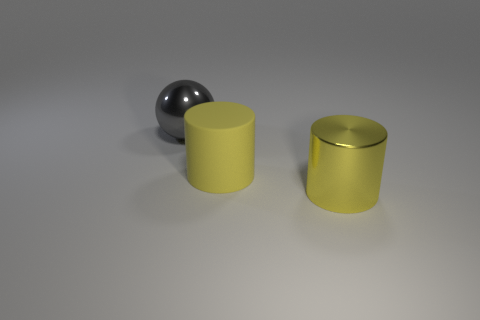Does the rubber cylinder have the same color as the large thing that is right of the large yellow matte cylinder?
Your answer should be compact. Yes. What number of tiny objects are there?
Offer a very short reply. 0. How many shiny objects are big yellow objects or gray objects?
Give a very brief answer. 2. How many metal things have the same color as the large metallic cylinder?
Offer a very short reply. 0. What material is the gray thing left of the big cylinder on the right side of the yellow matte object made of?
Give a very brief answer. Metal. What is the size of the matte cylinder?
Provide a short and direct response. Large. How many brown things are the same size as the gray object?
Offer a terse response. 0. How many other objects are the same shape as the large yellow rubber object?
Offer a very short reply. 1. Is the number of big yellow metal things that are behind the gray sphere the same as the number of large red metallic objects?
Your answer should be very brief. Yes. What shape is the yellow metal object that is the same size as the gray metallic thing?
Your answer should be compact. Cylinder. 